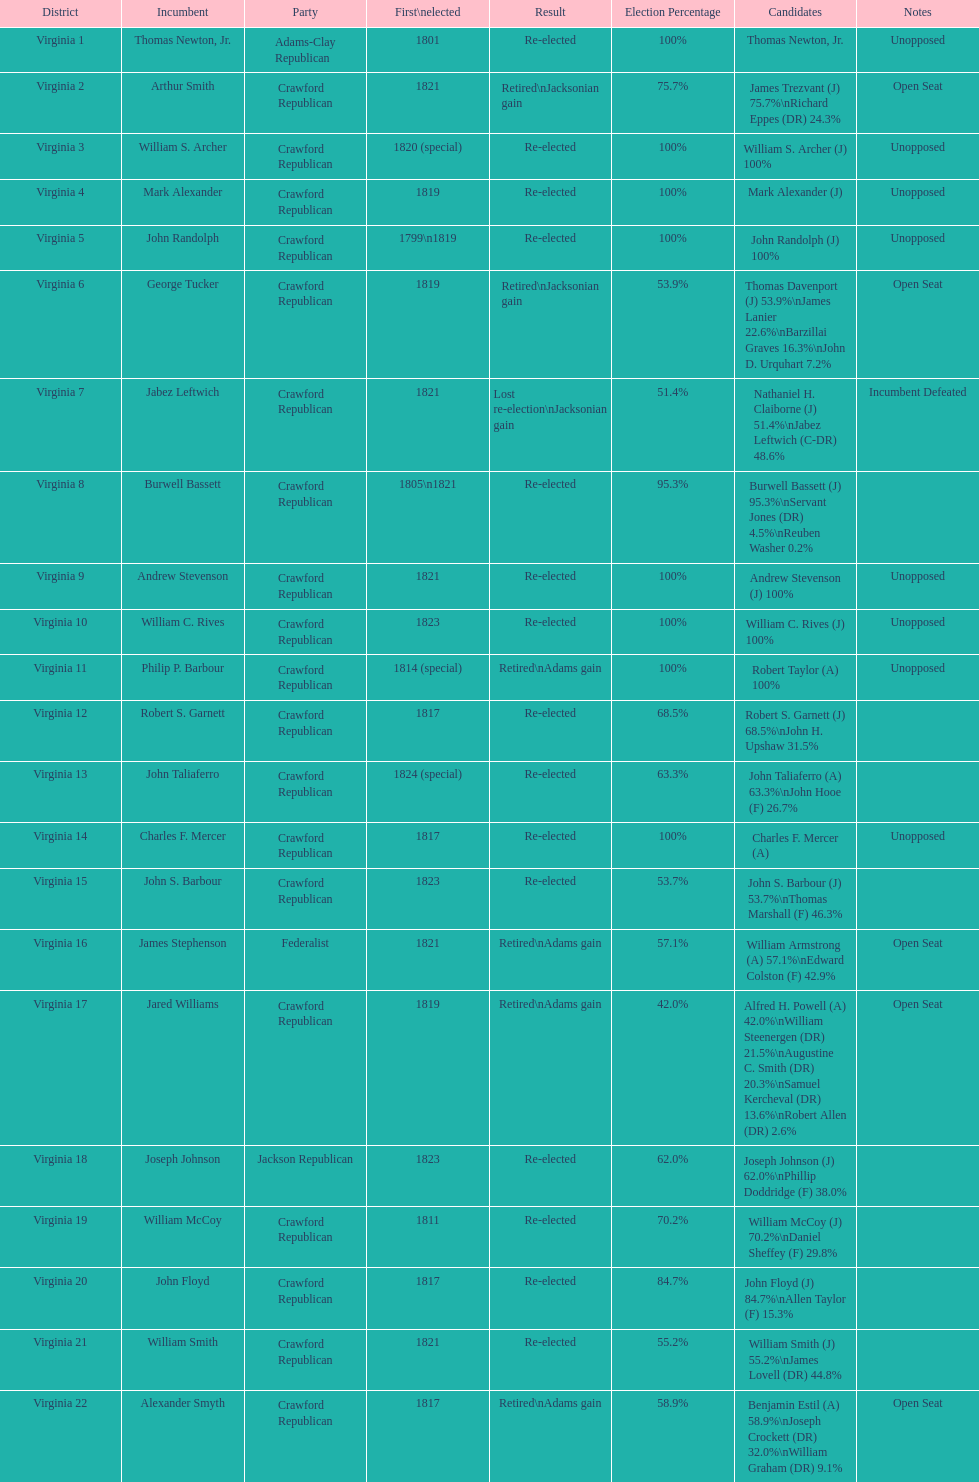How many districts are there in virginia? 22. 